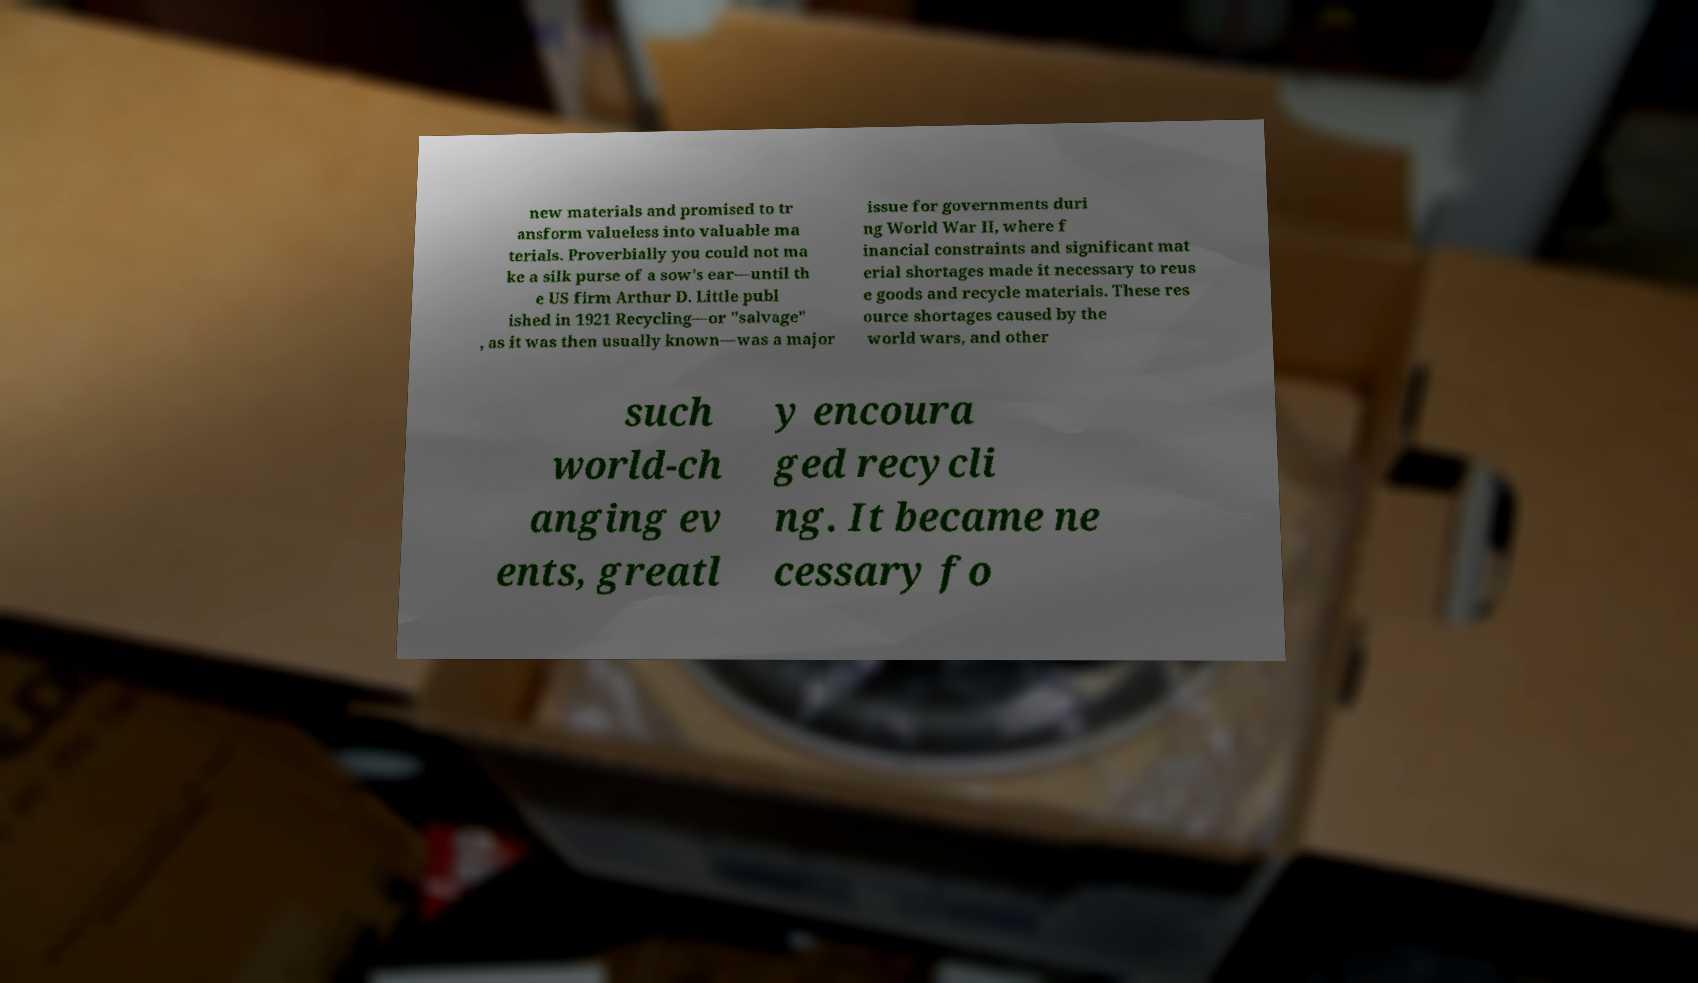Could you assist in decoding the text presented in this image and type it out clearly? new materials and promised to tr ansform valueless into valuable ma terials. Proverbially you could not ma ke a silk purse of a sow's ear—until th e US firm Arthur D. Little publ ished in 1921 Recycling—or "salvage" , as it was then usually known—was a major issue for governments duri ng World War II, where f inancial constraints and significant mat erial shortages made it necessary to reus e goods and recycle materials. These res ource shortages caused by the world wars, and other such world-ch anging ev ents, greatl y encoura ged recycli ng. It became ne cessary fo 